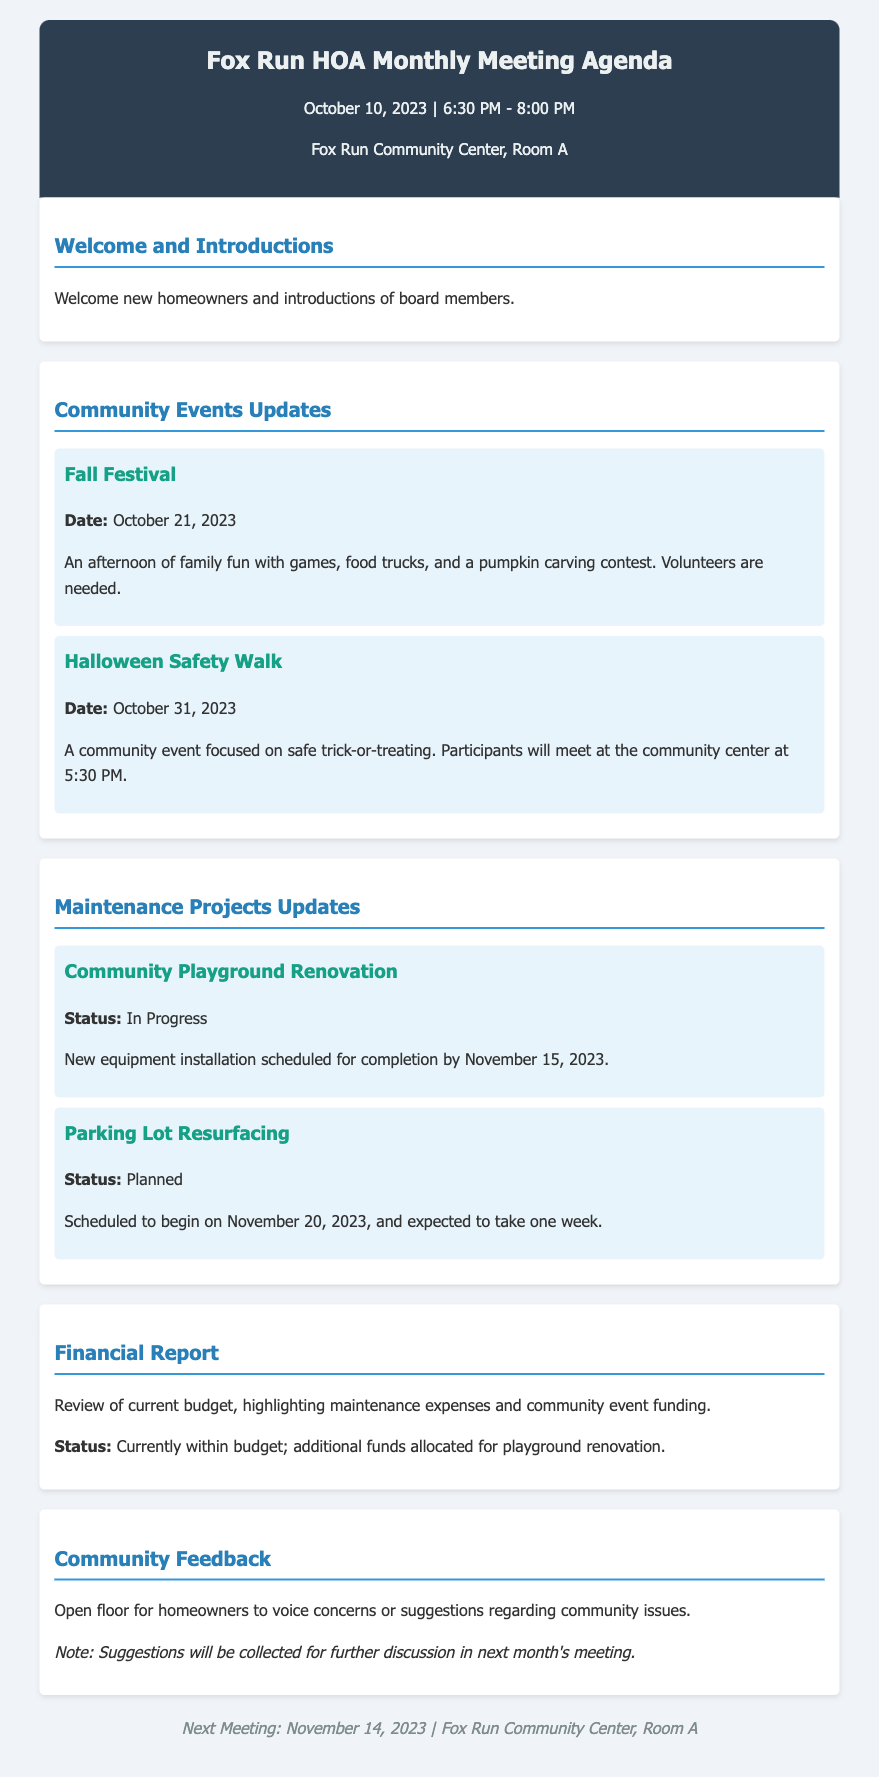What is the date of the Fall Festival? The document mentions that the Fall Festival is scheduled for October 21, 2023.
Answer: October 21, 2023 What time does the Halloween Safety Walk start? The document states that participants will meet at 5:30 PM for the Halloween Safety Walk.
Answer: 5:30 PM What is the status of the Community Playground Renovation? The Community Playground Renovation is listed as "In Progress" in the maintenance projects section.
Answer: In Progress When is the next HOA meeting scheduled? The footer of the document indicates that the next meeting will be on November 14, 2023.
Answer: November 14, 2023 How long is the Parking Lot Resurfacing expected to take? According to the document, the Parking Lot Resurfacing is expected to take one week.
Answer: One week Which event is focused on safe trick-or-treating? The document identifies the "Halloween Safety Walk" as the event focused on safe trick-or-treating.
Answer: Halloween Safety Walk What type of event is the Fall Festival described as? The document describes the Fall Festival as an "afternoon of family fun" including games, food trucks, and a pumpkin carving contest.
Answer: Family fun What will be discussed during the Community Feedback section? The document notes that homeowners can voice concerns or suggestions regarding community issues in the Community Feedback section.
Answer: Homeowners' concerns or suggestions 